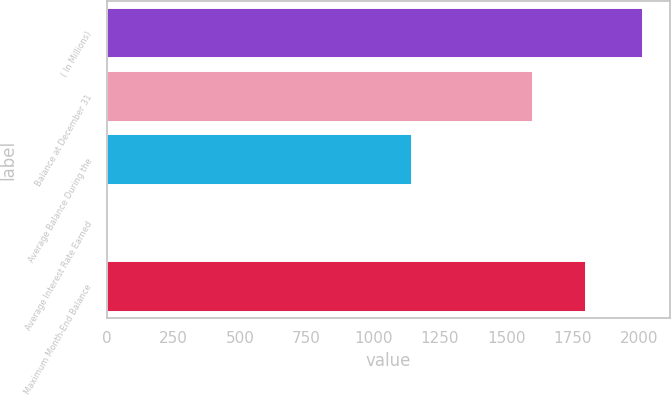<chart> <loc_0><loc_0><loc_500><loc_500><bar_chart><fcel>( In Millions)<fcel>Balance at December 31<fcel>Average Balance During the<fcel>Average Interest Rate Earned<fcel>Maximum Month-End Balance<nl><fcel>2015<fcel>1600<fcel>1144.7<fcel>0.54<fcel>1801.45<nl></chart> 